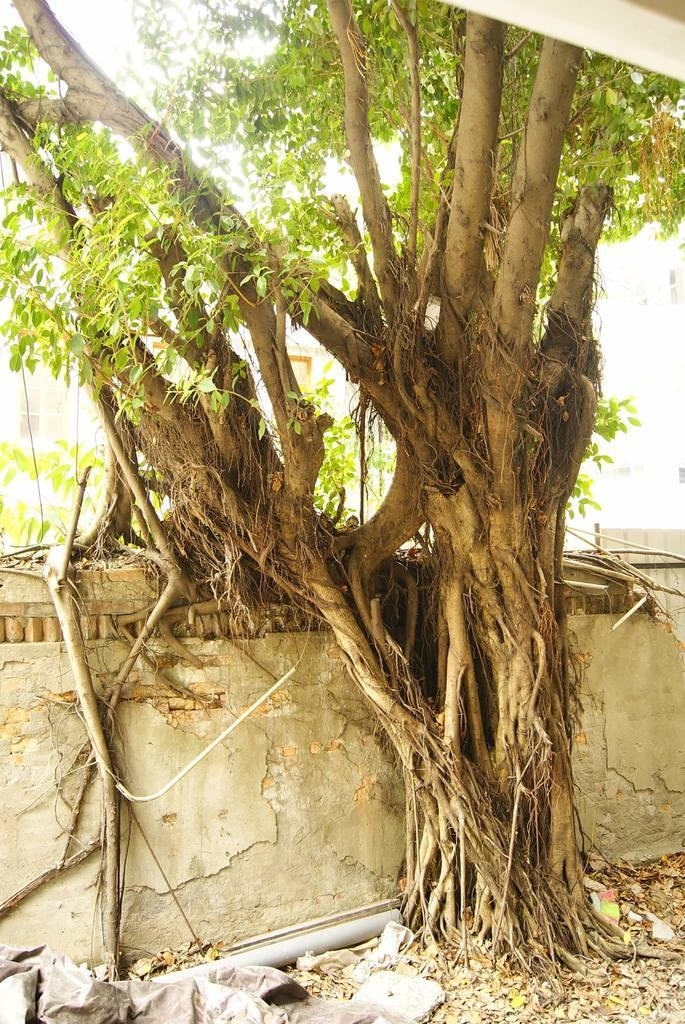What type of structure can be seen in the image? There is a wall in the image. What natural elements are present in the image? There are trees in the image. What is covering the ground in the image? Dried leaves are present on the ground. What else can be found on the ground in the image? There are objects on the ground. What type of vacation is the dad planning in the image? There is no reference to a vacation or a dad in the image, so it is not possible to answer that question. 